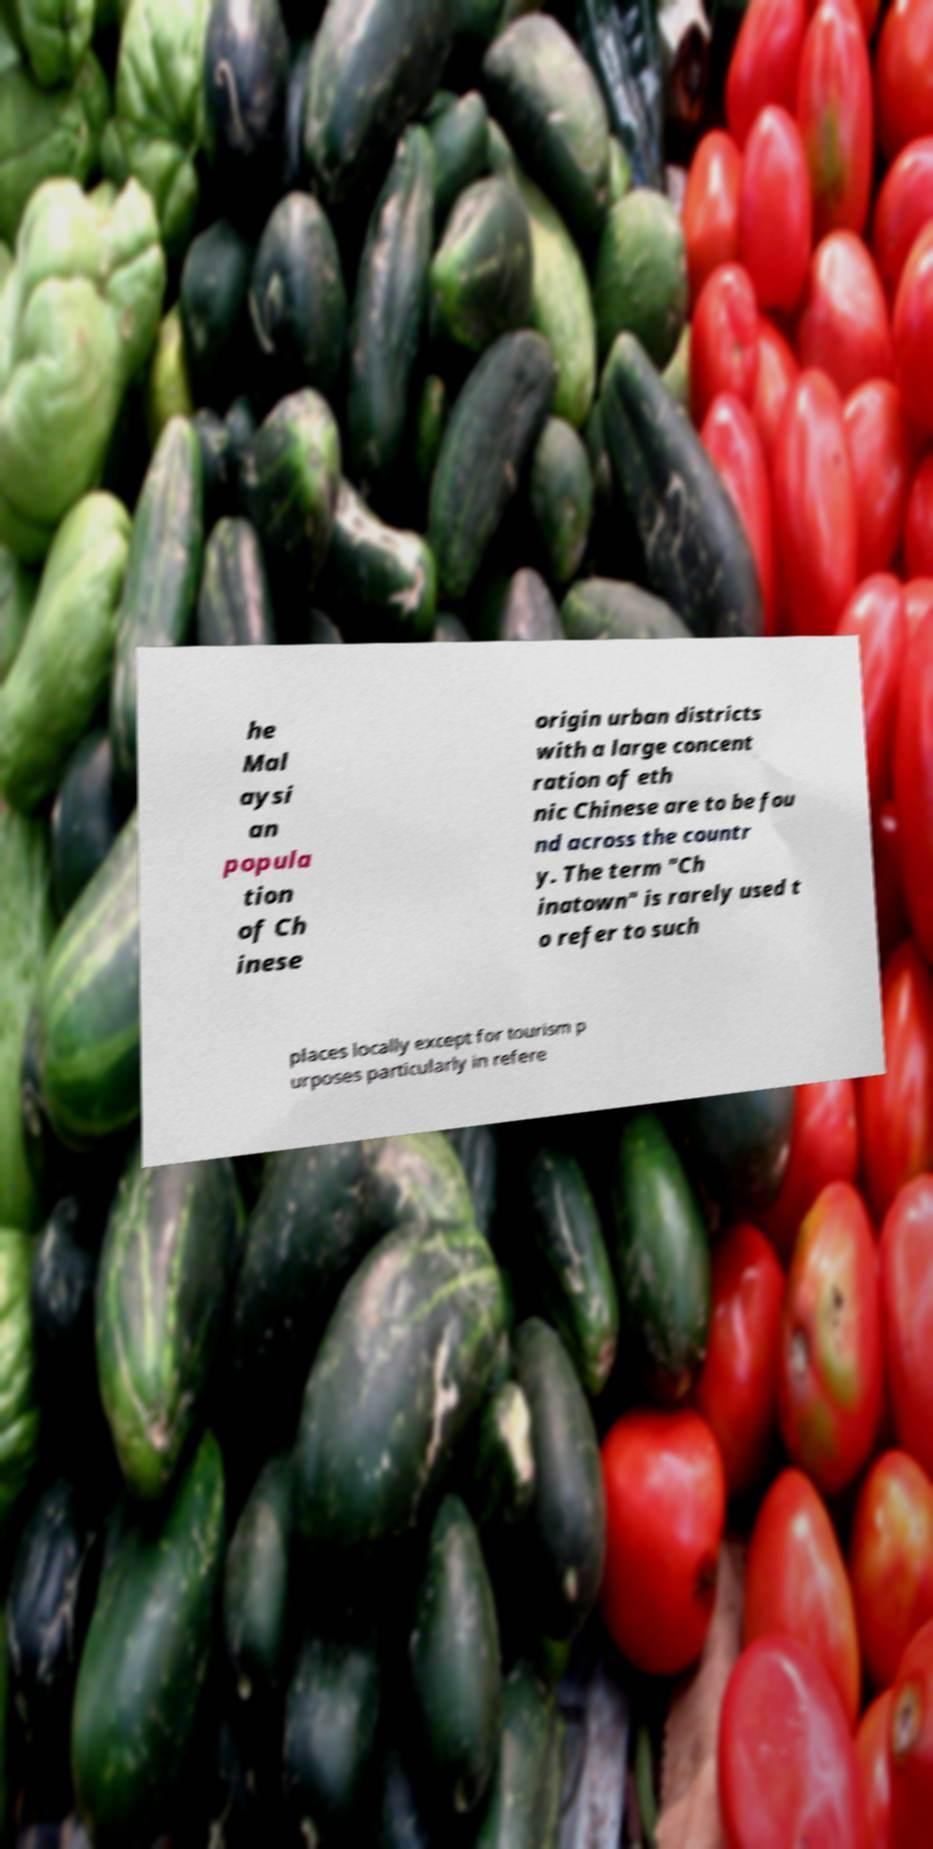There's text embedded in this image that I need extracted. Can you transcribe it verbatim? he Mal aysi an popula tion of Ch inese origin urban districts with a large concent ration of eth nic Chinese are to be fou nd across the countr y. The term "Ch inatown" is rarely used t o refer to such places locally except for tourism p urposes particularly in refere 